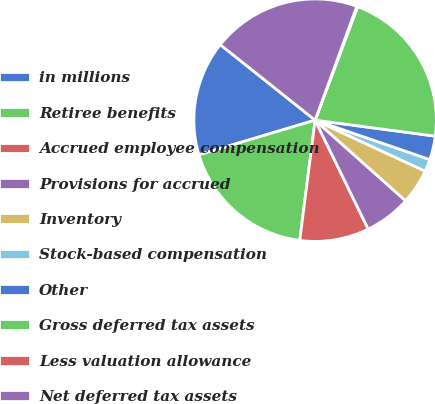Convert chart. <chart><loc_0><loc_0><loc_500><loc_500><pie_chart><fcel>in millions<fcel>Retiree benefits<fcel>Accrued employee compensation<fcel>Provisions for accrued<fcel>Inventory<fcel>Stock-based compensation<fcel>Other<fcel>Gross deferred tax assets<fcel>Less valuation allowance<fcel>Net deferred tax assets<nl><fcel>15.32%<fcel>18.36%<fcel>9.24%<fcel>6.2%<fcel>4.68%<fcel>1.64%<fcel>3.16%<fcel>21.4%<fcel>0.12%<fcel>19.88%<nl></chart> 